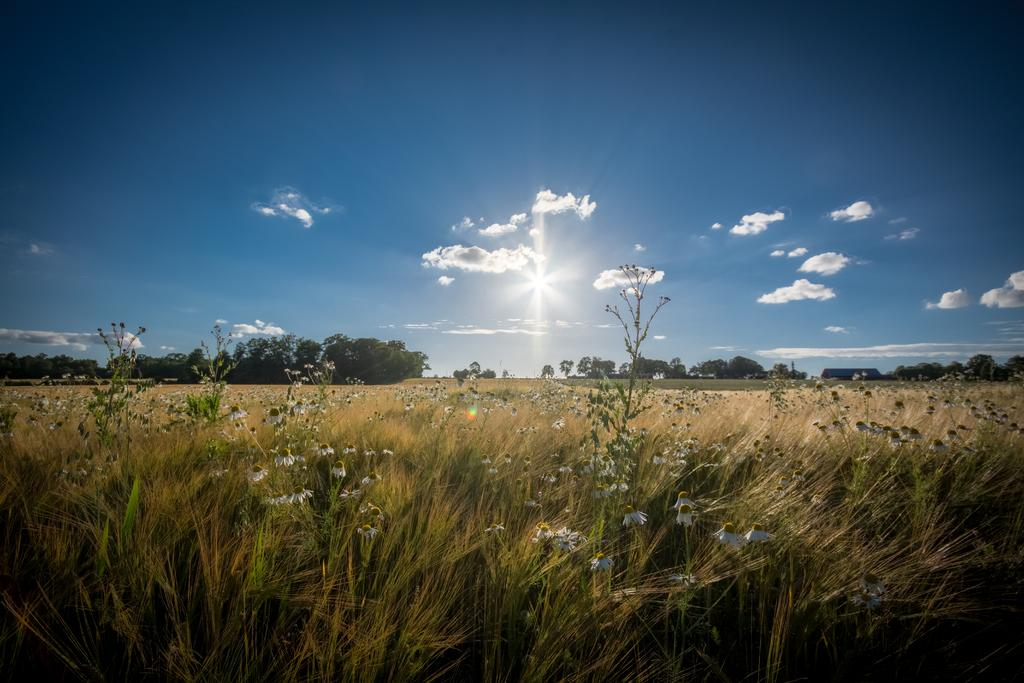What type of vegetation can be seen on the down side of the image? There is there any grass visible? What can be seen on the left side of the image? There are green plants on the left side of the image. What is visible in the middle of the image? The sky is visible in the middle of the image. What is the weather like in the image? The sky appears to be sunny, suggesting a clear and bright day. What type of engine is used to power the acoustics in the image? There is no engine or acoustics present in the image; it features grass, green plants, and a sunny sky. What government policy is being discussed in the image? There is no discussion or mention of government policy in the image. 